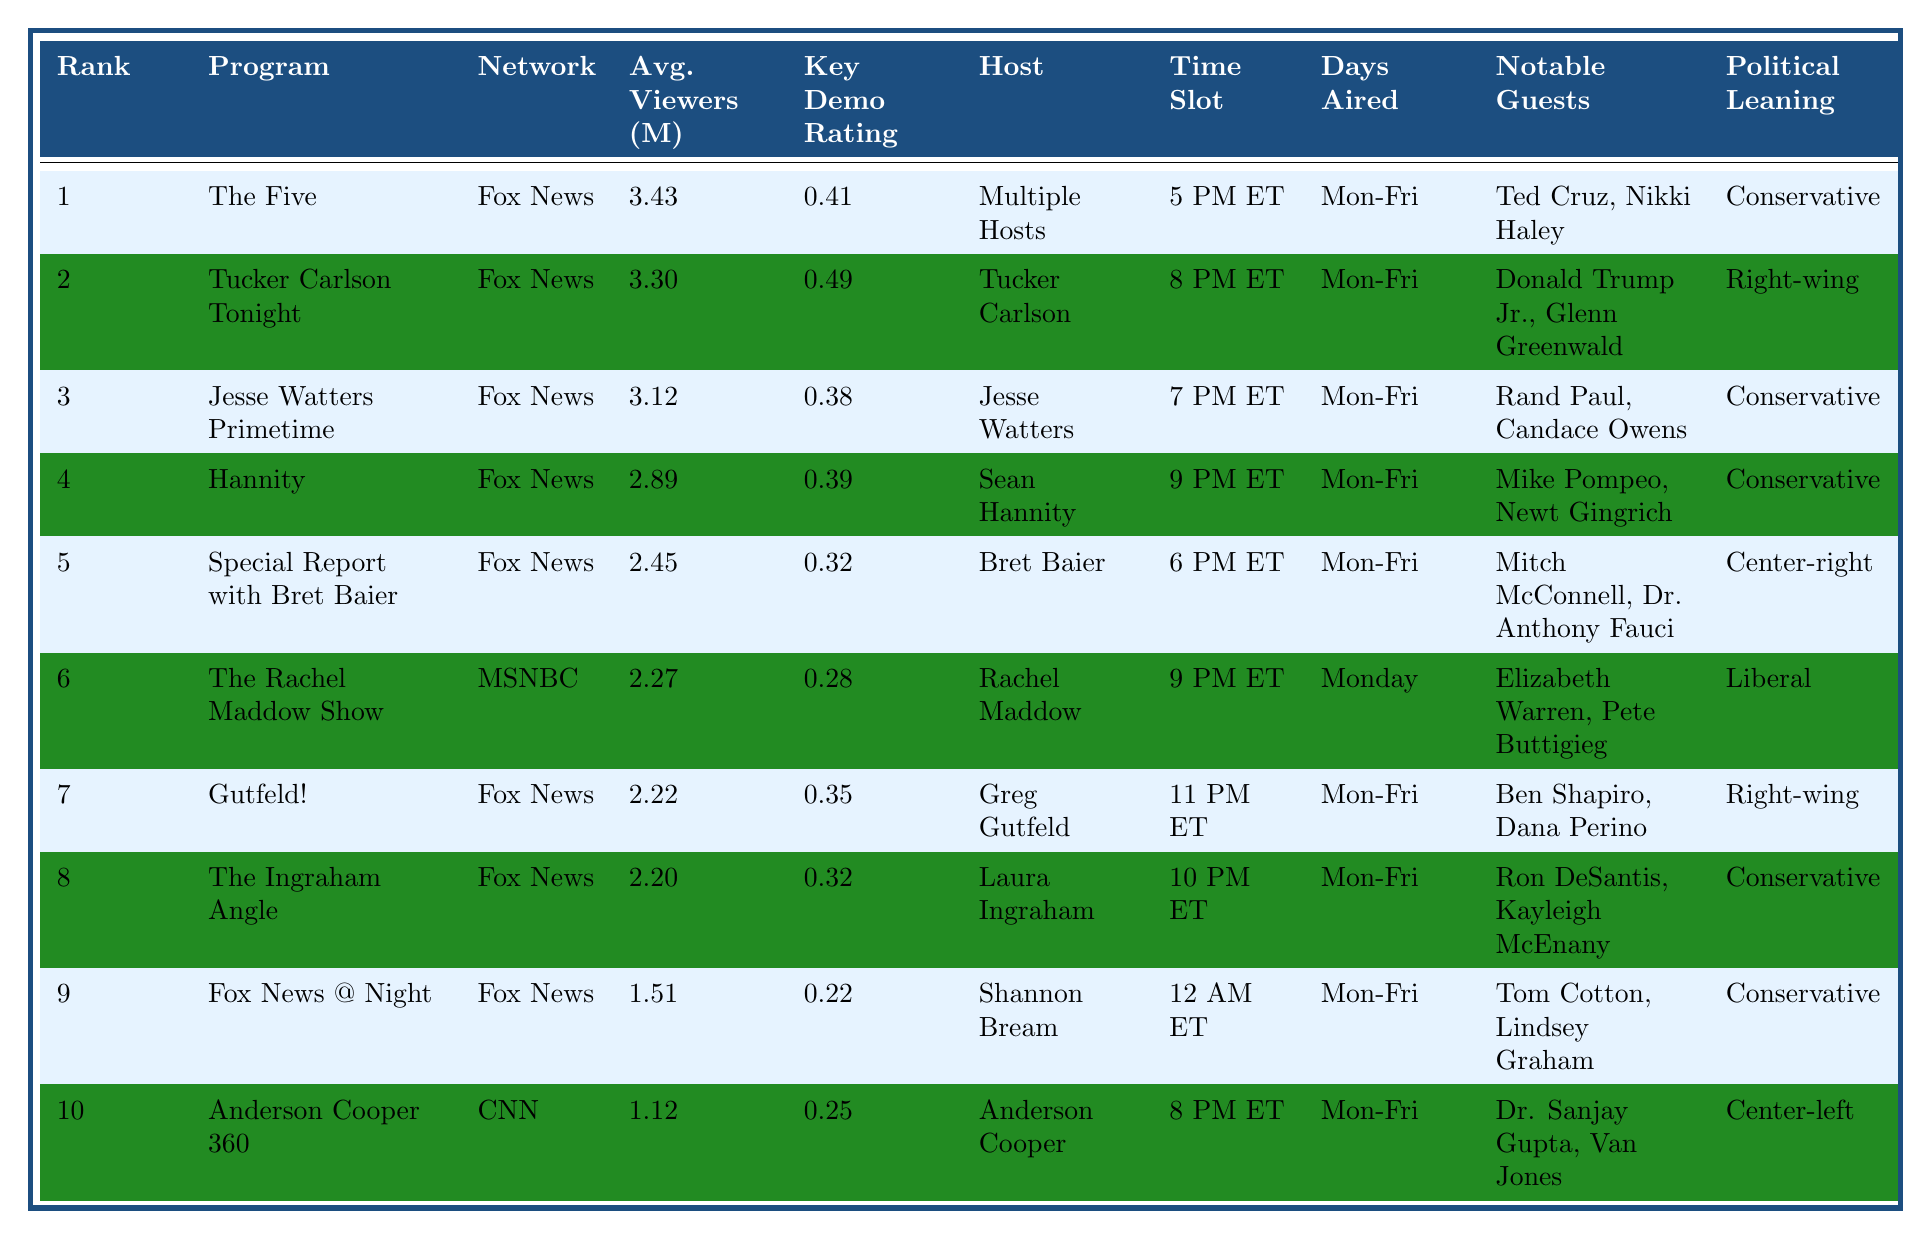What is the highest-ranked program on Fox News? The table shows that "The Five" is ranked 1 and it is also on Fox News.
Answer: The Five How many viewers does "Tucker Carlson Tonight" attract on average? "Tucker Carlson Tonight" has an average viewership of 3.30 million according to the table.
Answer: 3.30 million Which program has the highest Key Demo Rating (25-54)? By examining the Key Demo Rating column, "Tucker Carlson Tonight" has the highest rating at 0.49.
Answer: 0.49 Is "Anderson Cooper 360" a conservative program? The political leaning of "Anderson Cooper 360" is listed as "Center-left," which means it is not conservative.
Answer: No What is the average viewership of the top three programs? The average viewership of the top three programs can be calculated: (3.43 + 3.30 + 3.12) / 3 = 3.28 million.
Answer: 3.28 million How many programs have a Political Leaning categorized as "Conservative"? By counting from the Political Leaning column, there are 6 programs categorized as "Conservative."
Answer: 6 Which program has the most notable guests, based on the list provided? "The Five" includes notable guests such as Ted Cruz and Nikki Haley, but other programs like "The Ingraham Angle" also list prominent guests. However, "The Five" is the most-watched program overall.
Answer: The Five What time slot does "The Rachel Maddow Show" air? According to the table, "The Rachel Maddow Show" is scheduled for 9 PM ET.
Answer: 9 PM ET Which program has the lowest average viewership? The table indicates "Anderson Cooper 360" has the lowest average viewership at 1.12 million.
Answer: 1.12 million Do all the top 10 programs air on weekdays? The table specifies that "The Rachel Maddow Show" airs only on Monday, unlike the others which are Monday-Friday.
Answer: No 